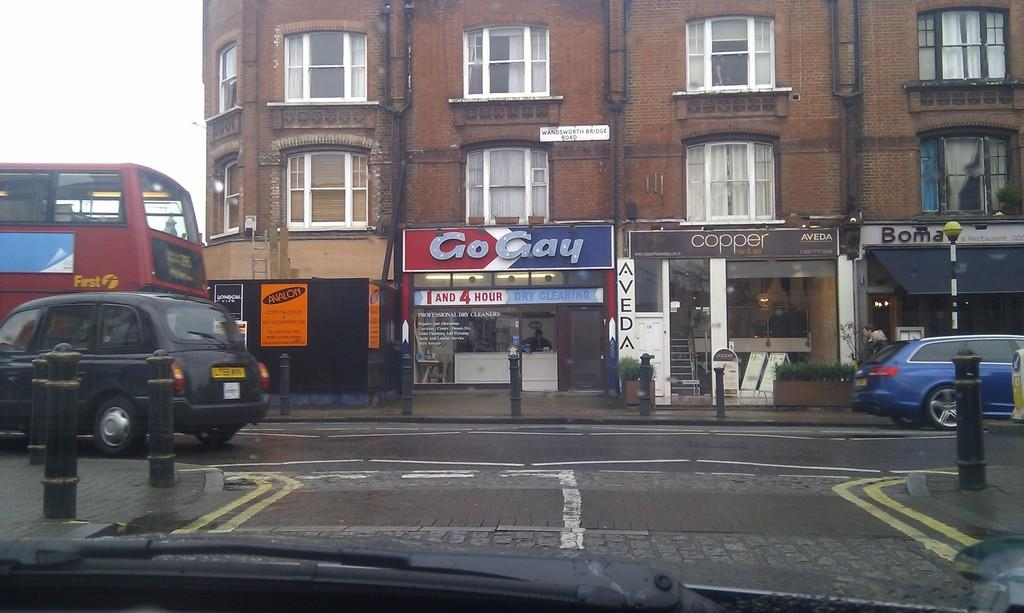<image>
Render a clear and concise summary of the photo. A shop called Go Gay is under a brown two storey building 